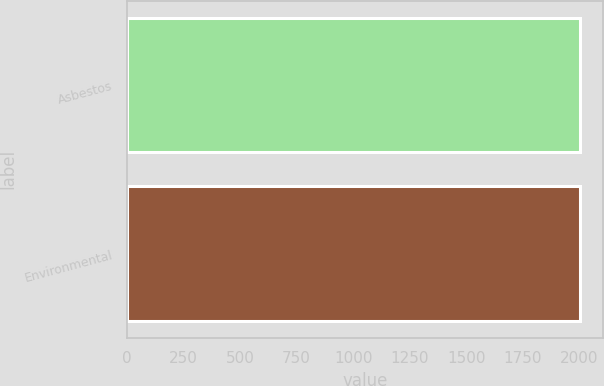Convert chart. <chart><loc_0><loc_0><loc_500><loc_500><bar_chart><fcel>Asbestos<fcel>Environmental<nl><fcel>2004<fcel>2004.1<nl></chart> 